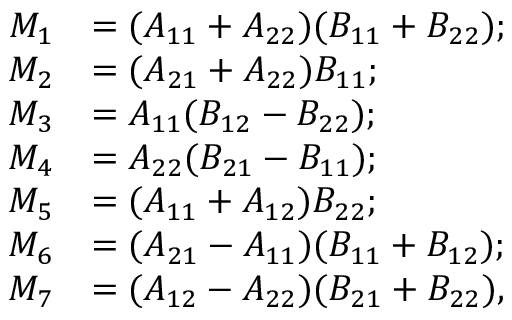Convert formula to latex. <formula><loc_0><loc_0><loc_500><loc_500>{ \begin{array} { r l } { M _ { 1 } } & { = ( A _ { 1 1 } + A _ { 2 2 } ) ( B _ { 1 1 } + B _ { 2 2 } ) ; } \\ { M _ { 2 } } & { = ( A _ { 2 1 } + A _ { 2 2 } ) B _ { 1 1 } ; } \\ { M _ { 3 } } & { = A _ { 1 1 } ( B _ { 1 2 } - B _ { 2 2 } ) ; } \\ { M _ { 4 } } & { = A _ { 2 2 } ( B _ { 2 1 } - B _ { 1 1 } ) ; } \\ { M _ { 5 } } & { = ( A _ { 1 1 } + A _ { 1 2 } ) B _ { 2 2 } ; } \\ { M _ { 6 } } & { = ( A _ { 2 1 } - A _ { 1 1 } ) ( B _ { 1 1 } + B _ { 1 2 } ) ; } \\ { M _ { 7 } } & { = ( A _ { 1 2 } - A _ { 2 2 } ) ( B _ { 2 1 } + B _ { 2 2 } ) , } \end{array} }</formula> 